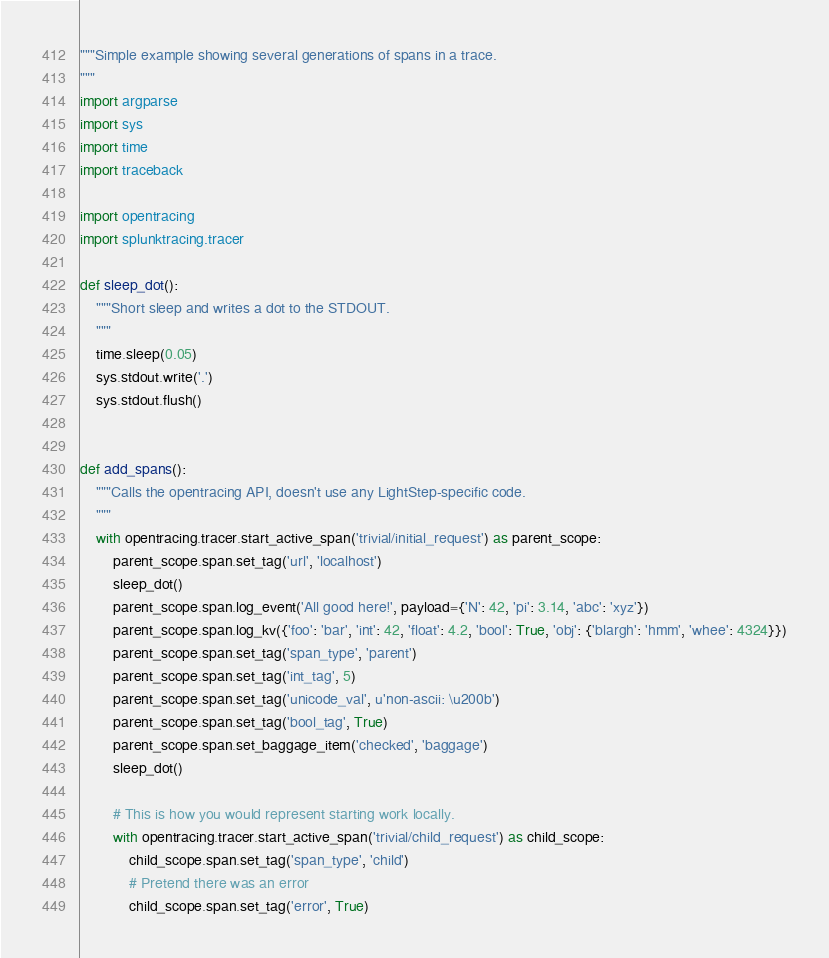Convert code to text. <code><loc_0><loc_0><loc_500><loc_500><_Python_>"""Simple example showing several generations of spans in a trace.
"""
import argparse
import sys
import time
import traceback

import opentracing
import splunktracing.tracer

def sleep_dot():
    """Short sleep and writes a dot to the STDOUT.
    """
    time.sleep(0.05)
    sys.stdout.write('.')
    sys.stdout.flush()


def add_spans():
    """Calls the opentracing API, doesn't use any LightStep-specific code.
    """
    with opentracing.tracer.start_active_span('trivial/initial_request') as parent_scope:
        parent_scope.span.set_tag('url', 'localhost')
        sleep_dot()
        parent_scope.span.log_event('All good here!', payload={'N': 42, 'pi': 3.14, 'abc': 'xyz'})
        parent_scope.span.log_kv({'foo': 'bar', 'int': 42, 'float': 4.2, 'bool': True, 'obj': {'blargh': 'hmm', 'whee': 4324}})
        parent_scope.span.set_tag('span_type', 'parent')
        parent_scope.span.set_tag('int_tag', 5)
        parent_scope.span.set_tag('unicode_val', u'non-ascii: \u200b')
        parent_scope.span.set_tag('bool_tag', True)
        parent_scope.span.set_baggage_item('checked', 'baggage')
        sleep_dot()

        # This is how you would represent starting work locally.
        with opentracing.tracer.start_active_span('trivial/child_request') as child_scope:
            child_scope.span.set_tag('span_type', 'child')
            # Pretend there was an error
            child_scope.span.set_tag('error', True)</code> 